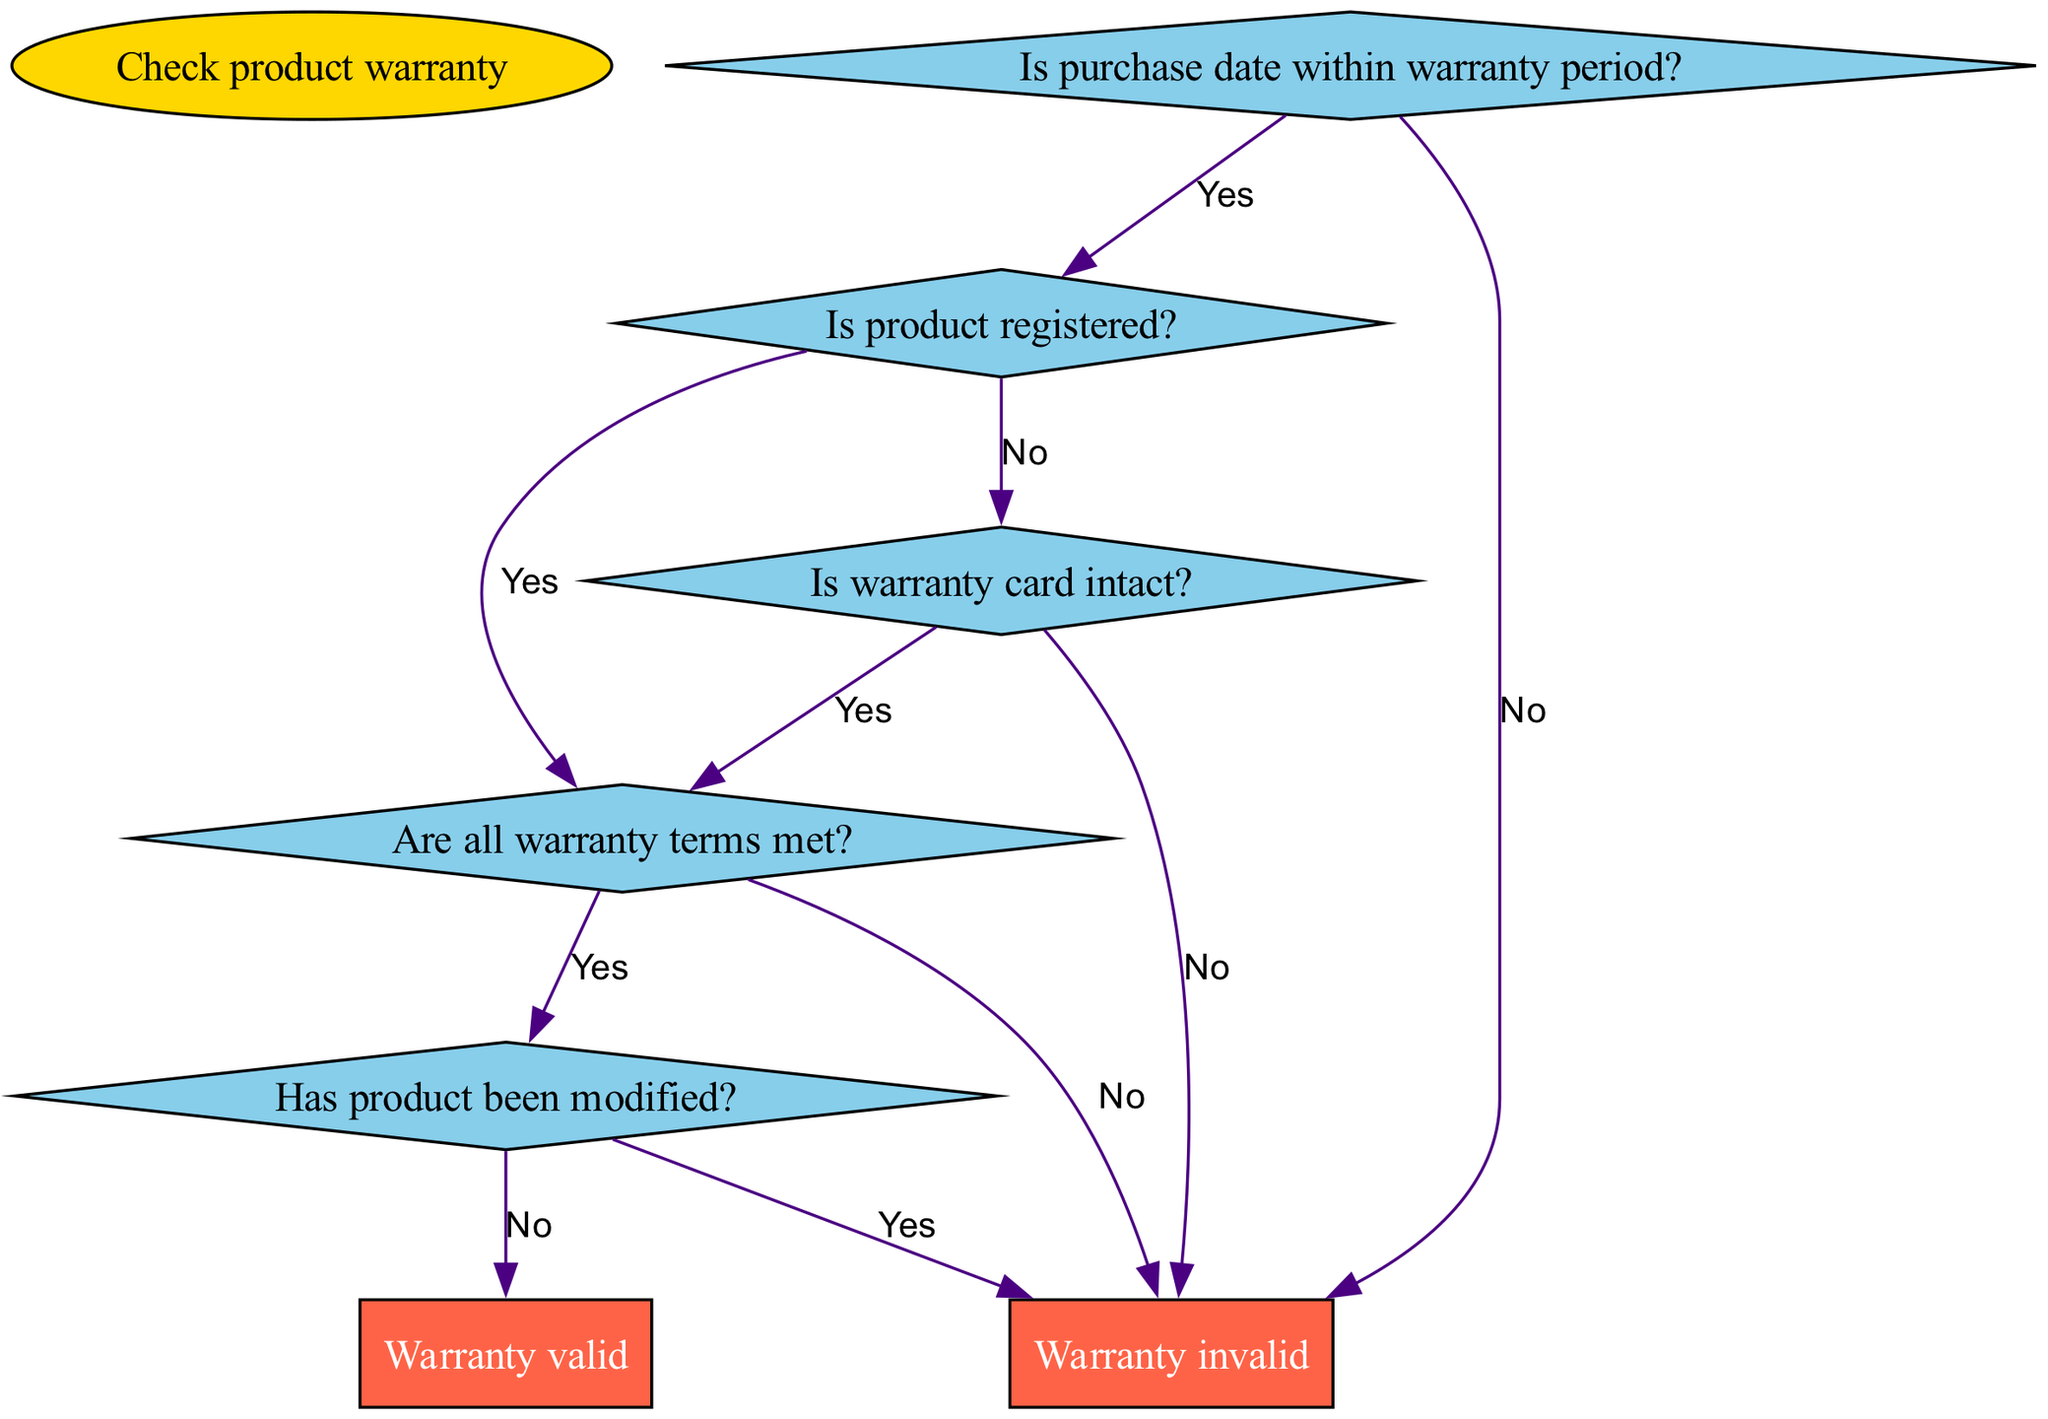What is the first question in the diagram? The first question node is labeled "Is purchase date within warranty period?" which is where the decision process begins.
Answer: Is purchase date within warranty period? How many nodes are there in total? The diagram contains one start node, five decision nodes, one valid node, and one end node, making a total of seven nodes.
Answer: Seven What happens if the product is not registered? If the product is not registered, the diagram shows it leads directly to the end node labeled "Warranty invalid".
Answer: Warranty invalid If a product's warranty terms are not met, what is the result? If the warranty terms are not met according to the decision process, it leads to the end node indicating "Warranty invalid".
Answer: Warranty invalid What is the outcome if the product has been modified? The flowchart states that modification leads to the end node, which indicates that the warranty is invalid under such circumstances.
Answer: Warranty invalid How many paths lead to a "Warranty valid" outcome? There is only one clear path that leads to a "Warranty valid" outcome, which occurs if the purchase date is within warranty, the product is registered, all terms are met, and it hasn't been modified.
Answer: One What is the last question about the wear and tear of the warranty card? The last question checks "Is warranty card intact?" and depends on its response, either leading back to the decision of warranty terms met or to "Warranty invalid."
Answer: Is warranty card intact? What would happen if the warranty card is not intact? If the warranty card is not intact, the next step directs the flow to the end node, resulting in "Warranty invalid".
Answer: Warranty invalid 